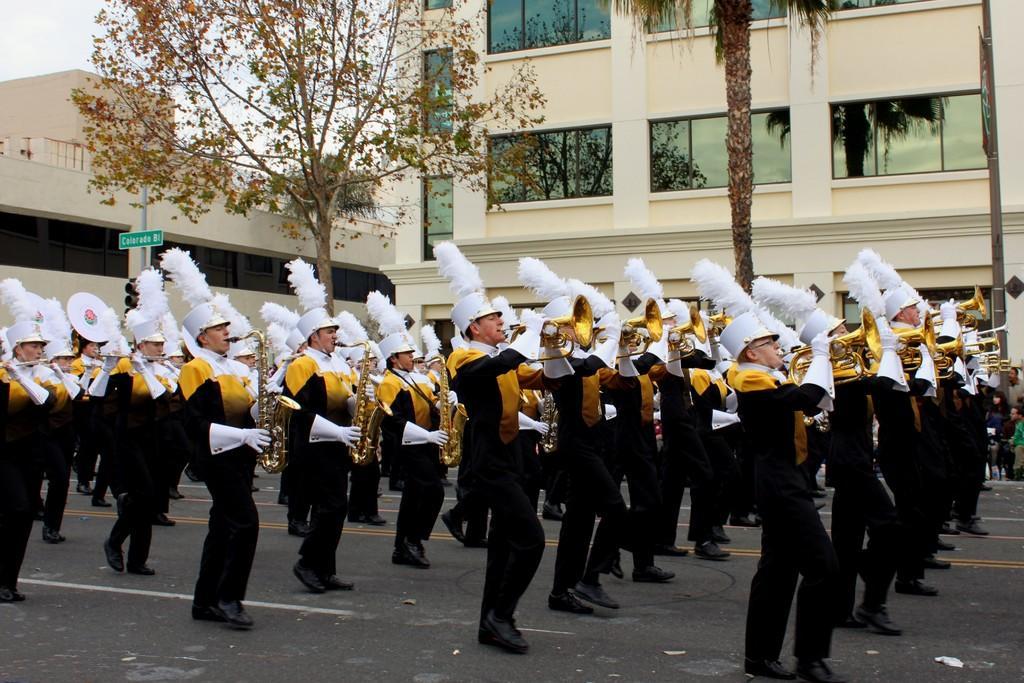Could you give a brief overview of what you see in this image? In this image we can see some people are marching on the road with holding a musical instrument in their hands. We can also see some trees and building in the background. There is a pole and a board attached to it and we can also see some text on the board. 